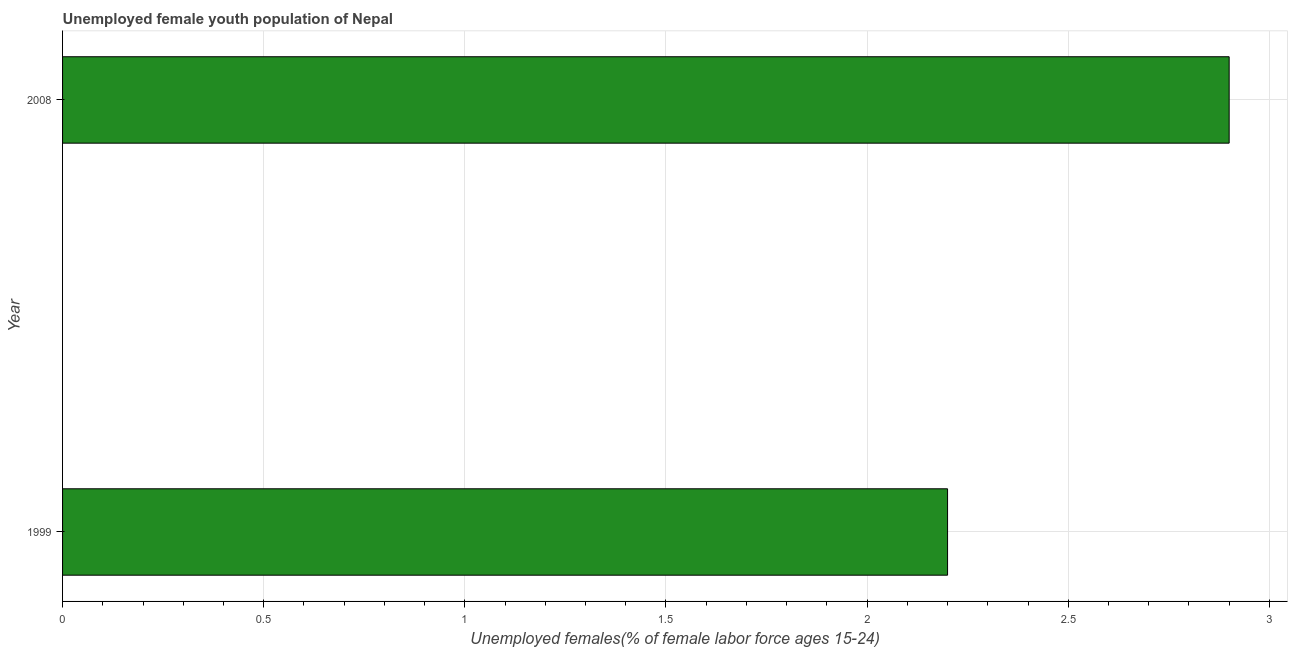Does the graph contain any zero values?
Provide a short and direct response. No. What is the title of the graph?
Ensure brevity in your answer.  Unemployed female youth population of Nepal. What is the label or title of the X-axis?
Your answer should be compact. Unemployed females(% of female labor force ages 15-24). What is the unemployed female youth in 1999?
Offer a very short reply. 2.2. Across all years, what is the maximum unemployed female youth?
Give a very brief answer. 2.9. Across all years, what is the minimum unemployed female youth?
Your answer should be compact. 2.2. What is the sum of the unemployed female youth?
Offer a terse response. 5.1. What is the difference between the unemployed female youth in 1999 and 2008?
Offer a very short reply. -0.7. What is the average unemployed female youth per year?
Your response must be concise. 2.55. What is the median unemployed female youth?
Provide a short and direct response. 2.55. In how many years, is the unemployed female youth greater than 1.6 %?
Offer a very short reply. 2. What is the ratio of the unemployed female youth in 1999 to that in 2008?
Offer a terse response. 0.76. Is the unemployed female youth in 1999 less than that in 2008?
Your answer should be compact. Yes. Are all the bars in the graph horizontal?
Your response must be concise. Yes. How many years are there in the graph?
Offer a terse response. 2. Are the values on the major ticks of X-axis written in scientific E-notation?
Your answer should be compact. No. What is the Unemployed females(% of female labor force ages 15-24) of 1999?
Give a very brief answer. 2.2. What is the Unemployed females(% of female labor force ages 15-24) of 2008?
Your answer should be very brief. 2.9. What is the ratio of the Unemployed females(% of female labor force ages 15-24) in 1999 to that in 2008?
Ensure brevity in your answer.  0.76. 